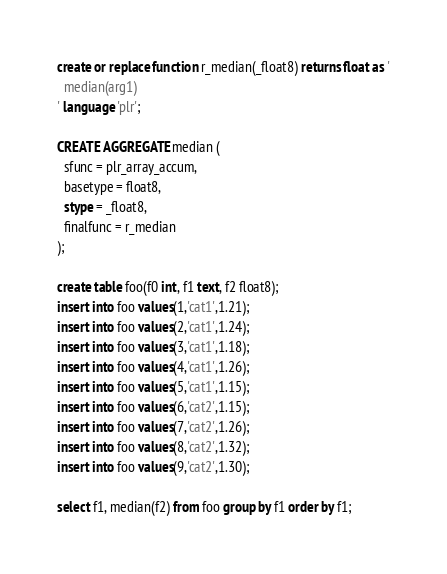<code> <loc_0><loc_0><loc_500><loc_500><_SQL_>create or replace function r_median(_float8) returns float as '
  median(arg1)
' language 'plr';

CREATE AGGREGATE median (
  sfunc = plr_array_accum,
  basetype = float8,
  stype = _float8,
  finalfunc = r_median
);

create table foo(f0 int, f1 text, f2 float8);
insert into foo values(1,'cat1',1.21);
insert into foo values(2,'cat1',1.24);
insert into foo values(3,'cat1',1.18);
insert into foo values(4,'cat1',1.26);
insert into foo values(5,'cat1',1.15);
insert into foo values(6,'cat2',1.15);
insert into foo values(7,'cat2',1.26);
insert into foo values(8,'cat2',1.32);
insert into foo values(9,'cat2',1.30);

select f1, median(f2) from foo group by f1 order by f1;
</code> 